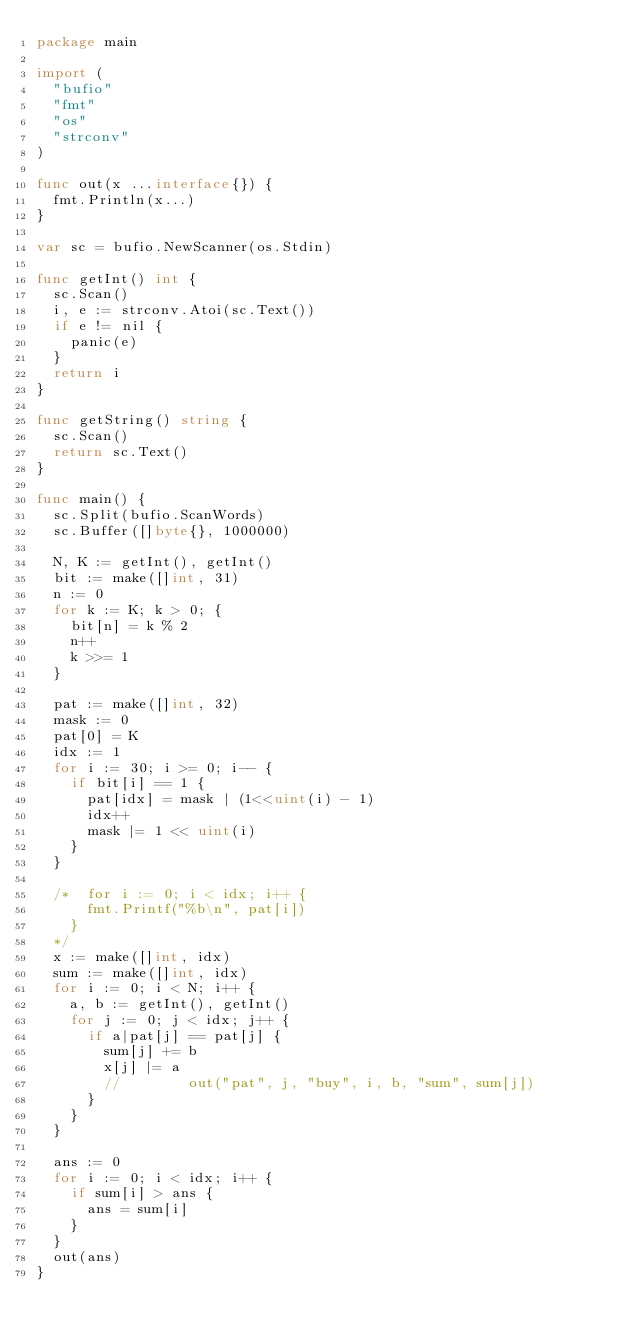Convert code to text. <code><loc_0><loc_0><loc_500><loc_500><_Go_>package main

import (
	"bufio"
	"fmt"
	"os"
	"strconv"
)

func out(x ...interface{}) {
	fmt.Println(x...)
}

var sc = bufio.NewScanner(os.Stdin)

func getInt() int {
	sc.Scan()
	i, e := strconv.Atoi(sc.Text())
	if e != nil {
		panic(e)
	}
	return i
}

func getString() string {
	sc.Scan()
	return sc.Text()
}

func main() {
	sc.Split(bufio.ScanWords)
	sc.Buffer([]byte{}, 1000000)

	N, K := getInt(), getInt()
	bit := make([]int, 31)
	n := 0
	for k := K; k > 0; {
		bit[n] = k % 2
		n++
		k >>= 1
	}

	pat := make([]int, 32)
	mask := 0
	pat[0] = K
	idx := 1
	for i := 30; i >= 0; i-- {
		if bit[i] == 1 {
			pat[idx] = mask | (1<<uint(i) - 1)
			idx++
			mask |= 1 << uint(i)
		}
	}

	/*	for i := 0; i < idx; i++ {
			fmt.Printf("%b\n", pat[i])
		}
	*/
	x := make([]int, idx)
	sum := make([]int, idx)
	for i := 0; i < N; i++ {
		a, b := getInt(), getInt()
		for j := 0; j < idx; j++ {
			if a|pat[j] == pat[j] {
				sum[j] += b
				x[j] |= a
				//				out("pat", j, "buy", i, b, "sum", sum[j])
			}
		}
	}

	ans := 0
	for i := 0; i < idx; i++ {
		if sum[i] > ans {
			ans = sum[i]
		}
	}
	out(ans)
}
</code> 